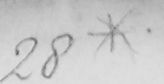Transcribe the text shown in this historical manuscript line. 28* 